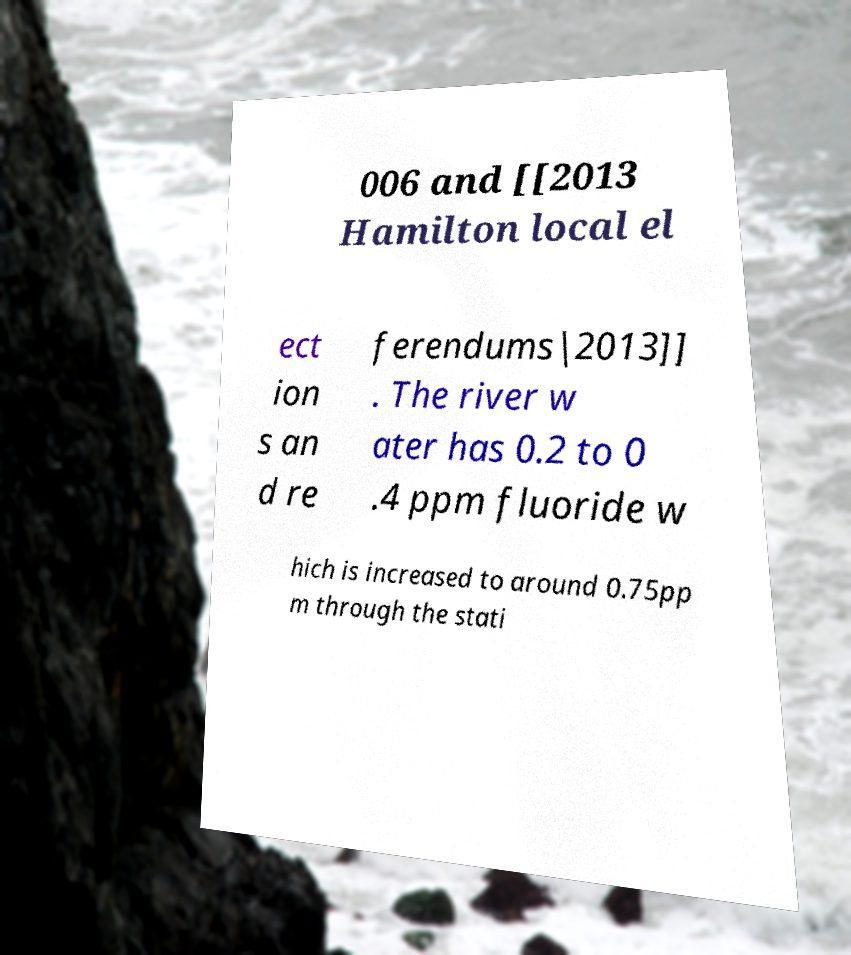Can you read and provide the text displayed in the image?This photo seems to have some interesting text. Can you extract and type it out for me? 006 and [[2013 Hamilton local el ect ion s an d re ferendums|2013]] . The river w ater has 0.2 to 0 .4 ppm fluoride w hich is increased to around 0.75pp m through the stati 